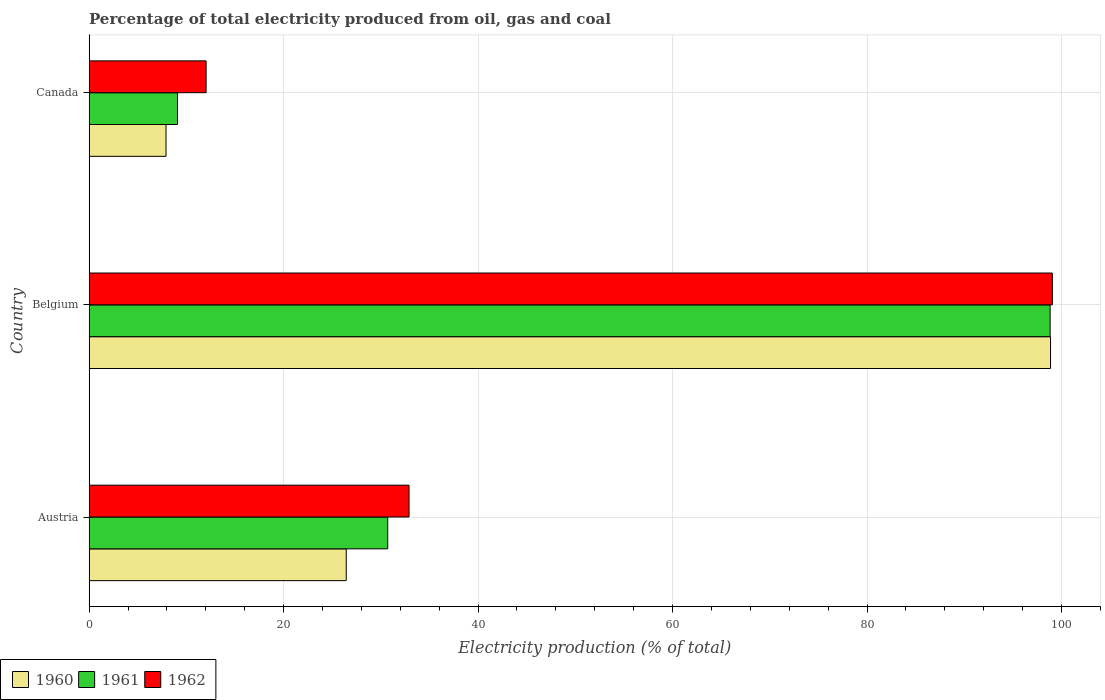How many bars are there on the 1st tick from the bottom?
Make the answer very short. 3. What is the electricity production in in 1961 in Austria?
Give a very brief answer. 30.71. Across all countries, what is the maximum electricity production in in 1961?
Offer a terse response. 98.82. Across all countries, what is the minimum electricity production in in 1961?
Your response must be concise. 9.09. In which country was the electricity production in in 1962 maximum?
Provide a succinct answer. Belgium. What is the total electricity production in in 1961 in the graph?
Offer a very short reply. 138.62. What is the difference between the electricity production in in 1960 in Austria and that in Canada?
Keep it short and to the point. 18.53. What is the difference between the electricity production in in 1962 in Canada and the electricity production in in 1960 in Austria?
Offer a terse response. -14.41. What is the average electricity production in in 1961 per country?
Give a very brief answer. 46.21. What is the difference between the electricity production in in 1962 and electricity production in in 1960 in Austria?
Provide a short and direct response. 6.46. In how many countries, is the electricity production in in 1962 greater than 64 %?
Provide a short and direct response. 1. What is the ratio of the electricity production in in 1961 in Austria to that in Canada?
Offer a very short reply. 3.38. What is the difference between the highest and the second highest electricity production in in 1960?
Provide a succinct answer. 72.42. What is the difference between the highest and the lowest electricity production in in 1962?
Your answer should be compact. 87.02. What does the 2nd bar from the top in Austria represents?
Provide a short and direct response. 1961. Is it the case that in every country, the sum of the electricity production in in 1961 and electricity production in in 1962 is greater than the electricity production in in 1960?
Your answer should be very brief. Yes. How many countries are there in the graph?
Provide a short and direct response. 3. Are the values on the major ticks of X-axis written in scientific E-notation?
Your answer should be very brief. No. Where does the legend appear in the graph?
Give a very brief answer. Bottom left. What is the title of the graph?
Your answer should be very brief. Percentage of total electricity produced from oil, gas and coal. Does "1996" appear as one of the legend labels in the graph?
Make the answer very short. No. What is the label or title of the X-axis?
Offer a very short reply. Electricity production (% of total). What is the Electricity production (% of total) in 1960 in Austria?
Ensure brevity in your answer.  26.44. What is the Electricity production (% of total) of 1961 in Austria?
Provide a short and direct response. 30.71. What is the Electricity production (% of total) of 1962 in Austria?
Offer a very short reply. 32.9. What is the Electricity production (% of total) of 1960 in Belgium?
Offer a very short reply. 98.86. What is the Electricity production (% of total) of 1961 in Belgium?
Make the answer very short. 98.82. What is the Electricity production (% of total) in 1962 in Belgium?
Ensure brevity in your answer.  99.05. What is the Electricity production (% of total) of 1960 in Canada?
Ensure brevity in your answer.  7.91. What is the Electricity production (% of total) in 1961 in Canada?
Your answer should be very brief. 9.09. What is the Electricity production (% of total) in 1962 in Canada?
Your answer should be very brief. 12.03. Across all countries, what is the maximum Electricity production (% of total) of 1960?
Keep it short and to the point. 98.86. Across all countries, what is the maximum Electricity production (% of total) of 1961?
Keep it short and to the point. 98.82. Across all countries, what is the maximum Electricity production (% of total) in 1962?
Provide a succinct answer. 99.05. Across all countries, what is the minimum Electricity production (% of total) of 1960?
Provide a short and direct response. 7.91. Across all countries, what is the minimum Electricity production (% of total) in 1961?
Offer a very short reply. 9.09. Across all countries, what is the minimum Electricity production (% of total) in 1962?
Your response must be concise. 12.03. What is the total Electricity production (% of total) of 1960 in the graph?
Your answer should be very brief. 133.22. What is the total Electricity production (% of total) of 1961 in the graph?
Provide a succinct answer. 138.62. What is the total Electricity production (% of total) in 1962 in the graph?
Offer a terse response. 143.98. What is the difference between the Electricity production (% of total) of 1960 in Austria and that in Belgium?
Make the answer very short. -72.42. What is the difference between the Electricity production (% of total) in 1961 in Austria and that in Belgium?
Your response must be concise. -68.11. What is the difference between the Electricity production (% of total) in 1962 in Austria and that in Belgium?
Your answer should be compact. -66.15. What is the difference between the Electricity production (% of total) of 1960 in Austria and that in Canada?
Your response must be concise. 18.53. What is the difference between the Electricity production (% of total) of 1961 in Austria and that in Canada?
Give a very brief answer. 21.62. What is the difference between the Electricity production (% of total) in 1962 in Austria and that in Canada?
Offer a very short reply. 20.87. What is the difference between the Electricity production (% of total) of 1960 in Belgium and that in Canada?
Make the answer very short. 90.95. What is the difference between the Electricity production (% of total) of 1961 in Belgium and that in Canada?
Offer a very short reply. 89.73. What is the difference between the Electricity production (% of total) in 1962 in Belgium and that in Canada?
Keep it short and to the point. 87.02. What is the difference between the Electricity production (% of total) of 1960 in Austria and the Electricity production (% of total) of 1961 in Belgium?
Offer a very short reply. -72.38. What is the difference between the Electricity production (% of total) of 1960 in Austria and the Electricity production (% of total) of 1962 in Belgium?
Your response must be concise. -72.61. What is the difference between the Electricity production (% of total) of 1961 in Austria and the Electricity production (% of total) of 1962 in Belgium?
Provide a short and direct response. -68.34. What is the difference between the Electricity production (% of total) of 1960 in Austria and the Electricity production (% of total) of 1961 in Canada?
Your response must be concise. 17.35. What is the difference between the Electricity production (% of total) in 1960 in Austria and the Electricity production (% of total) in 1962 in Canada?
Provide a succinct answer. 14.41. What is the difference between the Electricity production (% of total) of 1961 in Austria and the Electricity production (% of total) of 1962 in Canada?
Give a very brief answer. 18.67. What is the difference between the Electricity production (% of total) of 1960 in Belgium and the Electricity production (% of total) of 1961 in Canada?
Keep it short and to the point. 89.78. What is the difference between the Electricity production (% of total) of 1960 in Belgium and the Electricity production (% of total) of 1962 in Canada?
Make the answer very short. 86.83. What is the difference between the Electricity production (% of total) in 1961 in Belgium and the Electricity production (% of total) in 1962 in Canada?
Your response must be concise. 86.79. What is the average Electricity production (% of total) of 1960 per country?
Offer a terse response. 44.41. What is the average Electricity production (% of total) of 1961 per country?
Offer a terse response. 46.21. What is the average Electricity production (% of total) in 1962 per country?
Offer a terse response. 47.99. What is the difference between the Electricity production (% of total) in 1960 and Electricity production (% of total) in 1961 in Austria?
Keep it short and to the point. -4.27. What is the difference between the Electricity production (% of total) in 1960 and Electricity production (% of total) in 1962 in Austria?
Provide a short and direct response. -6.46. What is the difference between the Electricity production (% of total) of 1961 and Electricity production (% of total) of 1962 in Austria?
Ensure brevity in your answer.  -2.19. What is the difference between the Electricity production (% of total) of 1960 and Electricity production (% of total) of 1961 in Belgium?
Your response must be concise. 0.04. What is the difference between the Electricity production (% of total) in 1960 and Electricity production (% of total) in 1962 in Belgium?
Make the answer very short. -0.18. What is the difference between the Electricity production (% of total) in 1961 and Electricity production (% of total) in 1962 in Belgium?
Keep it short and to the point. -0.23. What is the difference between the Electricity production (% of total) of 1960 and Electricity production (% of total) of 1961 in Canada?
Make the answer very short. -1.18. What is the difference between the Electricity production (% of total) in 1960 and Electricity production (% of total) in 1962 in Canada?
Provide a short and direct response. -4.12. What is the difference between the Electricity production (% of total) of 1961 and Electricity production (% of total) of 1962 in Canada?
Your answer should be compact. -2.94. What is the ratio of the Electricity production (% of total) in 1960 in Austria to that in Belgium?
Offer a terse response. 0.27. What is the ratio of the Electricity production (% of total) in 1961 in Austria to that in Belgium?
Keep it short and to the point. 0.31. What is the ratio of the Electricity production (% of total) of 1962 in Austria to that in Belgium?
Offer a very short reply. 0.33. What is the ratio of the Electricity production (% of total) of 1960 in Austria to that in Canada?
Provide a succinct answer. 3.34. What is the ratio of the Electricity production (% of total) in 1961 in Austria to that in Canada?
Keep it short and to the point. 3.38. What is the ratio of the Electricity production (% of total) in 1962 in Austria to that in Canada?
Provide a succinct answer. 2.73. What is the ratio of the Electricity production (% of total) in 1960 in Belgium to that in Canada?
Your answer should be compact. 12.5. What is the ratio of the Electricity production (% of total) of 1961 in Belgium to that in Canada?
Your answer should be compact. 10.87. What is the ratio of the Electricity production (% of total) of 1962 in Belgium to that in Canada?
Your answer should be compact. 8.23. What is the difference between the highest and the second highest Electricity production (% of total) of 1960?
Give a very brief answer. 72.42. What is the difference between the highest and the second highest Electricity production (% of total) of 1961?
Ensure brevity in your answer.  68.11. What is the difference between the highest and the second highest Electricity production (% of total) in 1962?
Make the answer very short. 66.15. What is the difference between the highest and the lowest Electricity production (% of total) in 1960?
Ensure brevity in your answer.  90.95. What is the difference between the highest and the lowest Electricity production (% of total) in 1961?
Ensure brevity in your answer.  89.73. What is the difference between the highest and the lowest Electricity production (% of total) of 1962?
Provide a short and direct response. 87.02. 